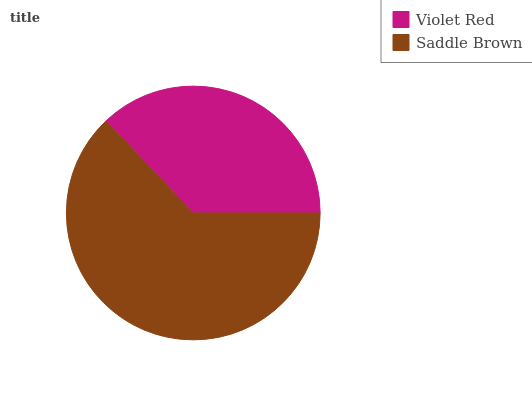Is Violet Red the minimum?
Answer yes or no. Yes. Is Saddle Brown the maximum?
Answer yes or no. Yes. Is Saddle Brown the minimum?
Answer yes or no. No. Is Saddle Brown greater than Violet Red?
Answer yes or no. Yes. Is Violet Red less than Saddle Brown?
Answer yes or no. Yes. Is Violet Red greater than Saddle Brown?
Answer yes or no. No. Is Saddle Brown less than Violet Red?
Answer yes or no. No. Is Saddle Brown the high median?
Answer yes or no. Yes. Is Violet Red the low median?
Answer yes or no. Yes. Is Violet Red the high median?
Answer yes or no. No. Is Saddle Brown the low median?
Answer yes or no. No. 